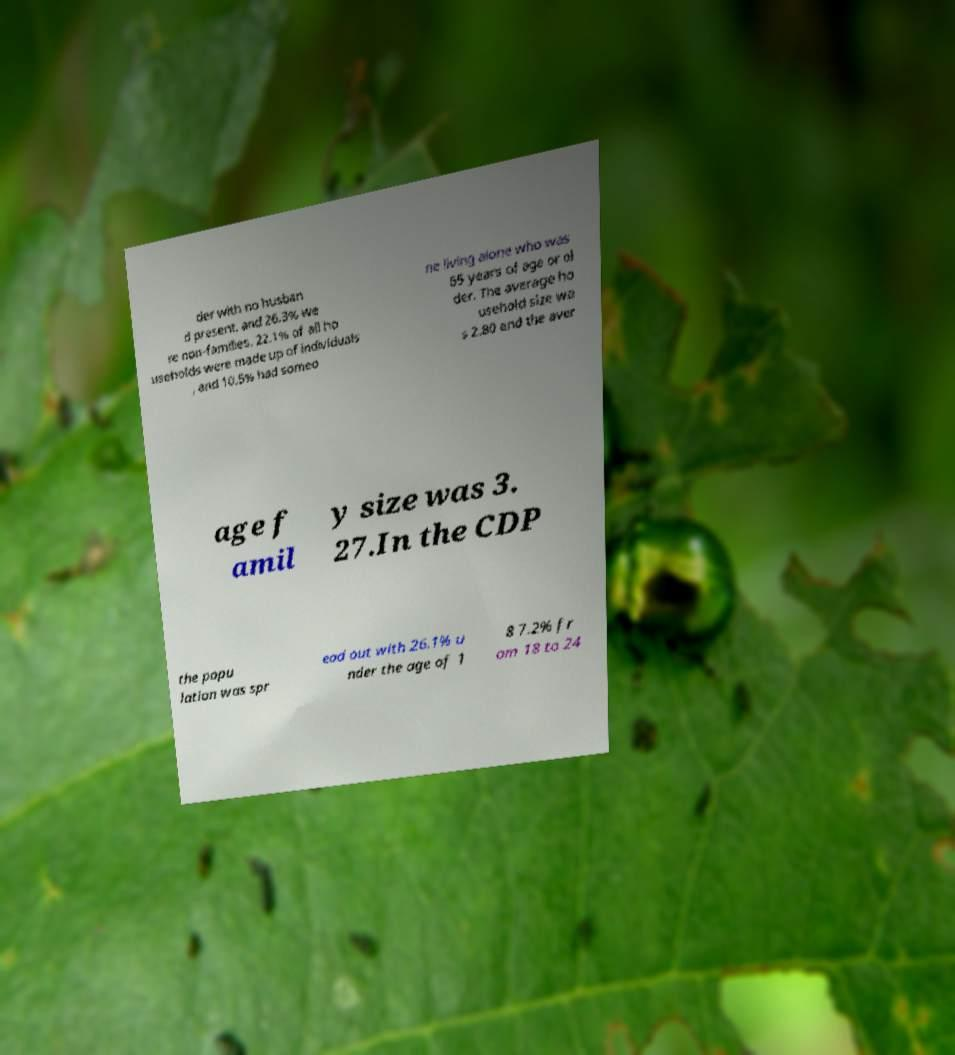For documentation purposes, I need the text within this image transcribed. Could you provide that? der with no husban d present, and 26.3% we re non-families. 22.1% of all ho useholds were made up of individuals , and 10.5% had someo ne living alone who was 65 years of age or ol der. The average ho usehold size wa s 2.80 and the aver age f amil y size was 3. 27.In the CDP the popu lation was spr ead out with 26.1% u nder the age of 1 8 7.2% fr om 18 to 24 